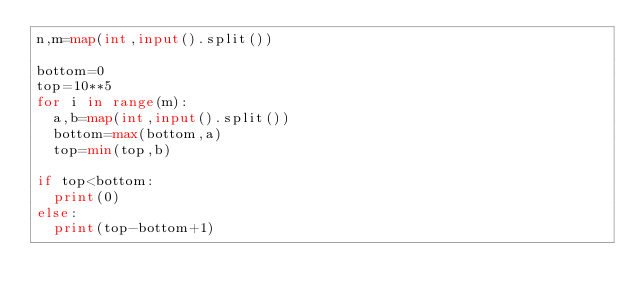Convert code to text. <code><loc_0><loc_0><loc_500><loc_500><_Python_>n,m=map(int,input().split())

bottom=0
top=10**5
for i in range(m):
  a,b=map(int,input().split())
  bottom=max(bottom,a)
  top=min(top,b)
  
if top<bottom:
  print(0)
else:
  print(top-bottom+1)
  </code> 